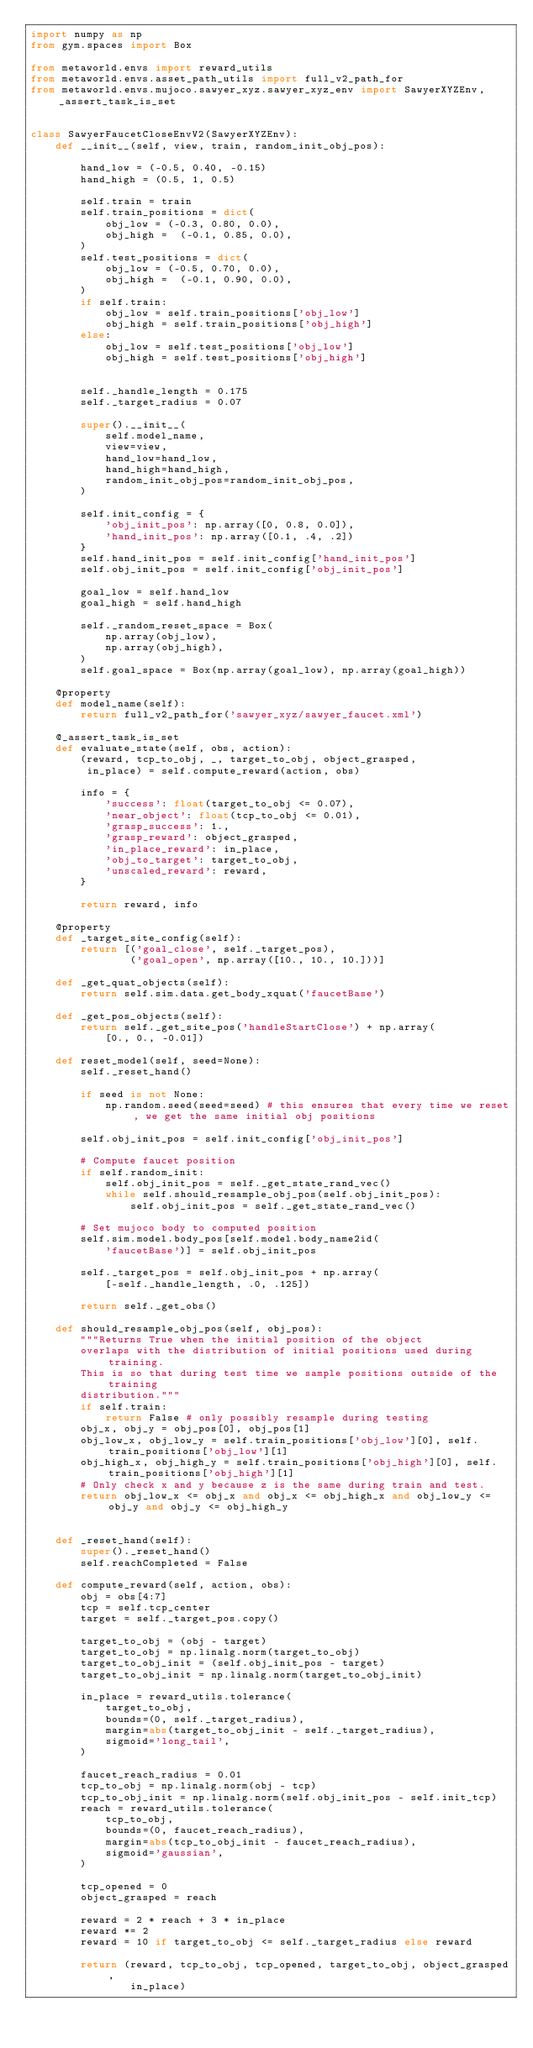Convert code to text. <code><loc_0><loc_0><loc_500><loc_500><_Python_>import numpy as np
from gym.spaces import Box

from metaworld.envs import reward_utils
from metaworld.envs.asset_path_utils import full_v2_path_for
from metaworld.envs.mujoco.sawyer_xyz.sawyer_xyz_env import SawyerXYZEnv, _assert_task_is_set


class SawyerFaucetCloseEnvV2(SawyerXYZEnv):
    def __init__(self, view, train, random_init_obj_pos):

        hand_low = (-0.5, 0.40, -0.15)
        hand_high = (0.5, 1, 0.5)

        self.train = train
        self.train_positions = dict(
            obj_low = (-0.3, 0.80, 0.0),
            obj_high =  (-0.1, 0.85, 0.0),
        )
        self.test_positions = dict(
            obj_low = (-0.5, 0.70, 0.0),
            obj_high =  (-0.1, 0.90, 0.0),
        )
        if self.train:
            obj_low = self.train_positions['obj_low']
            obj_high = self.train_positions['obj_high']
        else:
            obj_low = self.test_positions['obj_low']
            obj_high = self.test_positions['obj_high']


        self._handle_length = 0.175
        self._target_radius = 0.07

        super().__init__(
            self.model_name,
            view=view,
            hand_low=hand_low,
            hand_high=hand_high,
            random_init_obj_pos=random_init_obj_pos,
        )

        self.init_config = {
            'obj_init_pos': np.array([0, 0.8, 0.0]),
            'hand_init_pos': np.array([0.1, .4, .2])
        }
        self.hand_init_pos = self.init_config['hand_init_pos']
        self.obj_init_pos = self.init_config['obj_init_pos']

        goal_low = self.hand_low
        goal_high = self.hand_high

        self._random_reset_space = Box(
            np.array(obj_low),
            np.array(obj_high),
        )
        self.goal_space = Box(np.array(goal_low), np.array(goal_high))

    @property
    def model_name(self):
        return full_v2_path_for('sawyer_xyz/sawyer_faucet.xml')

    @_assert_task_is_set
    def evaluate_state(self, obs, action):
        (reward, tcp_to_obj, _, target_to_obj, object_grasped,
         in_place) = self.compute_reward(action, obs)

        info = {
            'success': float(target_to_obj <= 0.07),
            'near_object': float(tcp_to_obj <= 0.01),
            'grasp_success': 1.,
            'grasp_reward': object_grasped,
            'in_place_reward': in_place,
            'obj_to_target': target_to_obj,
            'unscaled_reward': reward,
        }

        return reward, info

    @property
    def _target_site_config(self):
        return [('goal_close', self._target_pos),
                ('goal_open', np.array([10., 10., 10.]))]

    def _get_quat_objects(self):
        return self.sim.data.get_body_xquat('faucetBase')

    def _get_pos_objects(self):
        return self._get_site_pos('handleStartClose') + np.array(
            [0., 0., -0.01])

    def reset_model(self, seed=None):
        self._reset_hand()

        if seed is not None:
            np.random.seed(seed=seed) # this ensures that every time we reset, we get the same initial obj positions

        self.obj_init_pos = self.init_config['obj_init_pos']

        # Compute faucet position
        if self.random_init:
            self.obj_init_pos = self._get_state_rand_vec()
            while self.should_resample_obj_pos(self.obj_init_pos):
                self.obj_init_pos = self._get_state_rand_vec()

        # Set mujoco body to computed position
        self.sim.model.body_pos[self.model.body_name2id(
            'faucetBase')] = self.obj_init_pos

        self._target_pos = self.obj_init_pos + np.array(
            [-self._handle_length, .0, .125])

        return self._get_obs()

    def should_resample_obj_pos(self, obj_pos):
        """Returns True when the initial position of the object
        overlaps with the distribution of initial positions used during training.
        This is so that during test time we sample positions outside of the training
        distribution."""
        if self.train:
            return False # only possibly resample during testing
        obj_x, obj_y = obj_pos[0], obj_pos[1]
        obj_low_x, obj_low_y = self.train_positions['obj_low'][0], self.train_positions['obj_low'][1]
        obj_high_x, obj_high_y = self.train_positions['obj_high'][0], self.train_positions['obj_high'][1]
        # Only check x and y because z is the same during train and test.
        return obj_low_x <= obj_x and obj_x <= obj_high_x and obj_low_y <= obj_y and obj_y <= obj_high_y


    def _reset_hand(self):
        super()._reset_hand()
        self.reachCompleted = False

    def compute_reward(self, action, obs):
        obj = obs[4:7]
        tcp = self.tcp_center
        target = self._target_pos.copy()

        target_to_obj = (obj - target)
        target_to_obj = np.linalg.norm(target_to_obj)
        target_to_obj_init = (self.obj_init_pos - target)
        target_to_obj_init = np.linalg.norm(target_to_obj_init)

        in_place = reward_utils.tolerance(
            target_to_obj,
            bounds=(0, self._target_radius),
            margin=abs(target_to_obj_init - self._target_radius),
            sigmoid='long_tail',
        )

        faucet_reach_radius = 0.01
        tcp_to_obj = np.linalg.norm(obj - tcp)
        tcp_to_obj_init = np.linalg.norm(self.obj_init_pos - self.init_tcp)
        reach = reward_utils.tolerance(
            tcp_to_obj,
            bounds=(0, faucet_reach_radius),
            margin=abs(tcp_to_obj_init - faucet_reach_radius),
            sigmoid='gaussian',
        )

        tcp_opened = 0
        object_grasped = reach

        reward = 2 * reach + 3 * in_place
        reward *= 2
        reward = 10 if target_to_obj <= self._target_radius else reward

        return (reward, tcp_to_obj, tcp_opened, target_to_obj, object_grasped,
                in_place)
</code> 